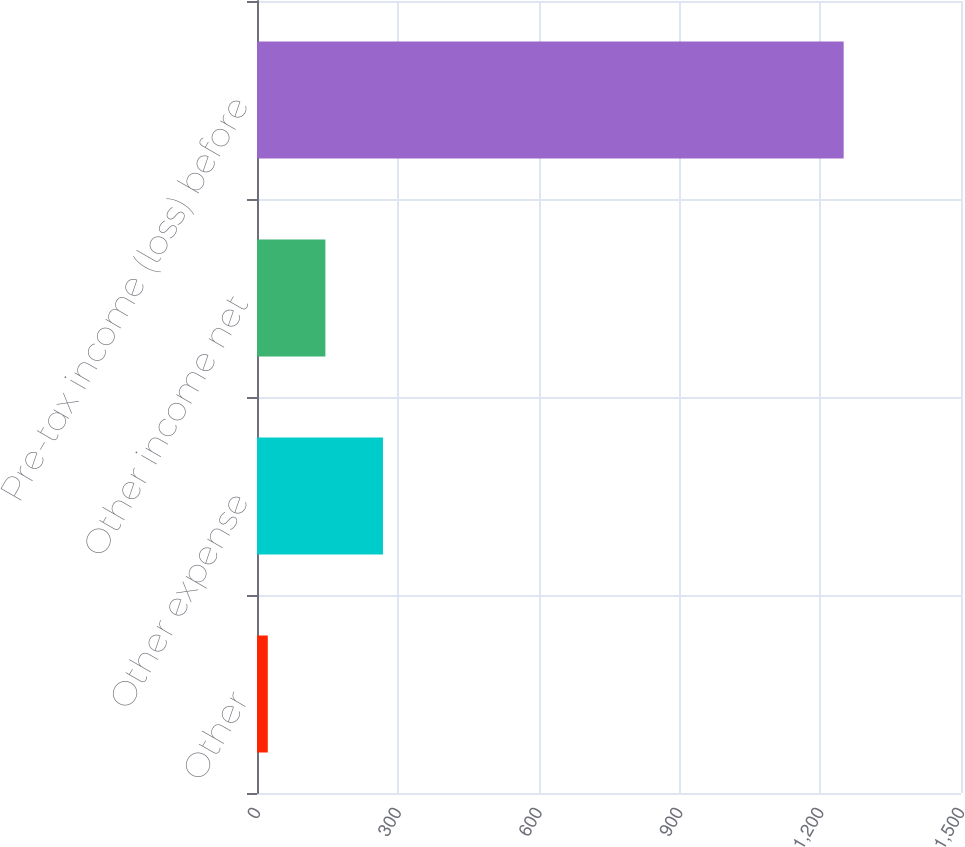Convert chart to OTSL. <chart><loc_0><loc_0><loc_500><loc_500><bar_chart><fcel>Other<fcel>Other expense<fcel>Other income net<fcel>Pre-tax income (loss) before<nl><fcel>23<fcel>268.4<fcel>145.7<fcel>1250<nl></chart> 